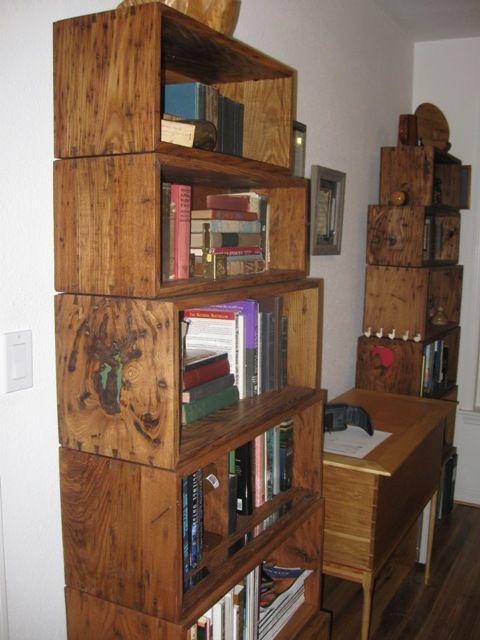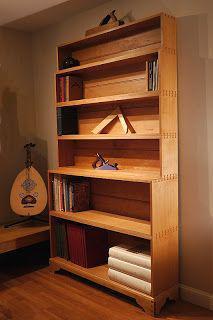The first image is the image on the left, the second image is the image on the right. For the images shown, is this caption "One of the images includes a bookcase with glass on the front." true? Answer yes or no. No. The first image is the image on the left, the second image is the image on the right. Assess this claim about the two images: "The cabinet in the left image has glass panes.". Correct or not? Answer yes or no. No. 